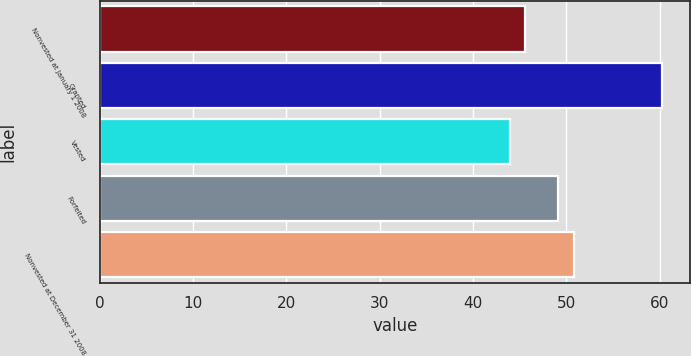Convert chart. <chart><loc_0><loc_0><loc_500><loc_500><bar_chart><fcel>Nonvested at January 1 2008<fcel>Granted<fcel>Vested<fcel>Forfeited<fcel>Nonvested at December 31 2008<nl><fcel>45.54<fcel>60.25<fcel>43.91<fcel>49.13<fcel>50.76<nl></chart> 